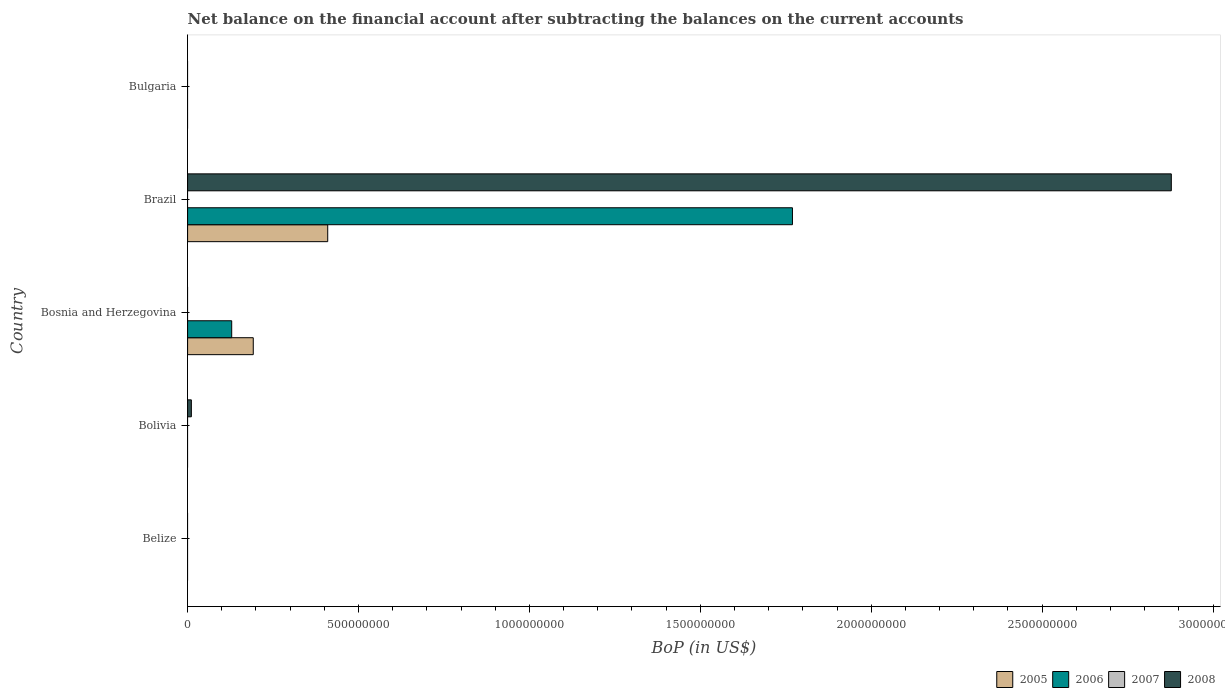How many different coloured bars are there?
Make the answer very short. 3. Are the number of bars per tick equal to the number of legend labels?
Provide a short and direct response. No. Are the number of bars on each tick of the Y-axis equal?
Your response must be concise. No. What is the label of the 2nd group of bars from the top?
Your answer should be very brief. Brazil. Across all countries, what is the maximum Balance of Payments in 2006?
Offer a very short reply. 1.77e+09. In which country was the Balance of Payments in 2006 maximum?
Keep it short and to the point. Brazil. What is the total Balance of Payments in 2005 in the graph?
Your response must be concise. 6.02e+08. What is the difference between the Balance of Payments in 2008 in Bolivia and that in Brazil?
Offer a very short reply. -2.87e+09. What is the difference between the Balance of Payments in 2006 in Brazil and the Balance of Payments in 2005 in Bosnia and Herzegovina?
Keep it short and to the point. 1.58e+09. What is the average Balance of Payments in 2007 per country?
Keep it short and to the point. 0. What is the difference between the Balance of Payments in 2006 and Balance of Payments in 2005 in Bosnia and Herzegovina?
Your response must be concise. -6.31e+07. In how many countries, is the Balance of Payments in 2007 greater than 600000000 US$?
Ensure brevity in your answer.  0. What is the ratio of the Balance of Payments in 2006 in Bosnia and Herzegovina to that in Brazil?
Offer a very short reply. 0.07. Is the Balance of Payments in 2006 in Bosnia and Herzegovina less than that in Brazil?
Offer a terse response. Yes. What is the difference between the highest and the lowest Balance of Payments in 2005?
Provide a short and direct response. 4.10e+08. In how many countries, is the Balance of Payments in 2006 greater than the average Balance of Payments in 2006 taken over all countries?
Make the answer very short. 1. Is the sum of the Balance of Payments in 2005 in Bosnia and Herzegovina and Brazil greater than the maximum Balance of Payments in 2006 across all countries?
Your response must be concise. No. What is the difference between two consecutive major ticks on the X-axis?
Your response must be concise. 5.00e+08. Does the graph contain any zero values?
Your answer should be compact. Yes. Does the graph contain grids?
Give a very brief answer. No. Where does the legend appear in the graph?
Give a very brief answer. Bottom right. How many legend labels are there?
Your answer should be compact. 4. What is the title of the graph?
Provide a succinct answer. Net balance on the financial account after subtracting the balances on the current accounts. What is the label or title of the X-axis?
Your answer should be very brief. BoP (in US$). What is the BoP (in US$) in 2005 in Belize?
Make the answer very short. 0. What is the BoP (in US$) in 2006 in Belize?
Give a very brief answer. 0. What is the BoP (in US$) of 2007 in Belize?
Ensure brevity in your answer.  0. What is the BoP (in US$) of 2005 in Bolivia?
Provide a succinct answer. 0. What is the BoP (in US$) of 2006 in Bolivia?
Provide a short and direct response. 0. What is the BoP (in US$) of 2007 in Bolivia?
Provide a short and direct response. 0. What is the BoP (in US$) in 2008 in Bolivia?
Your answer should be compact. 1.10e+07. What is the BoP (in US$) of 2005 in Bosnia and Herzegovina?
Offer a very short reply. 1.92e+08. What is the BoP (in US$) of 2006 in Bosnia and Herzegovina?
Keep it short and to the point. 1.29e+08. What is the BoP (in US$) of 2007 in Bosnia and Herzegovina?
Provide a short and direct response. 0. What is the BoP (in US$) of 2008 in Bosnia and Herzegovina?
Your answer should be very brief. 0. What is the BoP (in US$) in 2005 in Brazil?
Your response must be concise. 4.10e+08. What is the BoP (in US$) in 2006 in Brazil?
Keep it short and to the point. 1.77e+09. What is the BoP (in US$) of 2007 in Brazil?
Offer a very short reply. 0. What is the BoP (in US$) in 2008 in Brazil?
Provide a short and direct response. 2.88e+09. What is the BoP (in US$) in 2006 in Bulgaria?
Ensure brevity in your answer.  0. What is the BoP (in US$) in 2007 in Bulgaria?
Your answer should be compact. 0. What is the BoP (in US$) in 2008 in Bulgaria?
Keep it short and to the point. 0. Across all countries, what is the maximum BoP (in US$) in 2005?
Make the answer very short. 4.10e+08. Across all countries, what is the maximum BoP (in US$) of 2006?
Provide a succinct answer. 1.77e+09. Across all countries, what is the maximum BoP (in US$) of 2008?
Provide a succinct answer. 2.88e+09. Across all countries, what is the minimum BoP (in US$) in 2006?
Offer a terse response. 0. What is the total BoP (in US$) of 2005 in the graph?
Your response must be concise. 6.02e+08. What is the total BoP (in US$) in 2006 in the graph?
Provide a succinct answer. 1.90e+09. What is the total BoP (in US$) of 2007 in the graph?
Provide a succinct answer. 0. What is the total BoP (in US$) in 2008 in the graph?
Make the answer very short. 2.89e+09. What is the difference between the BoP (in US$) of 2008 in Bolivia and that in Brazil?
Your answer should be compact. -2.87e+09. What is the difference between the BoP (in US$) in 2005 in Bosnia and Herzegovina and that in Brazil?
Your answer should be compact. -2.18e+08. What is the difference between the BoP (in US$) of 2006 in Bosnia and Herzegovina and that in Brazil?
Your answer should be very brief. -1.64e+09. What is the difference between the BoP (in US$) of 2005 in Bosnia and Herzegovina and the BoP (in US$) of 2006 in Brazil?
Offer a very short reply. -1.58e+09. What is the difference between the BoP (in US$) of 2005 in Bosnia and Herzegovina and the BoP (in US$) of 2008 in Brazil?
Offer a terse response. -2.69e+09. What is the difference between the BoP (in US$) of 2006 in Bosnia and Herzegovina and the BoP (in US$) of 2008 in Brazil?
Provide a short and direct response. -2.75e+09. What is the average BoP (in US$) of 2005 per country?
Ensure brevity in your answer.  1.20e+08. What is the average BoP (in US$) in 2006 per country?
Your answer should be compact. 3.80e+08. What is the average BoP (in US$) of 2008 per country?
Your answer should be compact. 5.78e+08. What is the difference between the BoP (in US$) in 2005 and BoP (in US$) in 2006 in Bosnia and Herzegovina?
Give a very brief answer. 6.31e+07. What is the difference between the BoP (in US$) in 2005 and BoP (in US$) in 2006 in Brazil?
Your answer should be very brief. -1.36e+09. What is the difference between the BoP (in US$) in 2005 and BoP (in US$) in 2008 in Brazil?
Your answer should be very brief. -2.47e+09. What is the difference between the BoP (in US$) of 2006 and BoP (in US$) of 2008 in Brazil?
Offer a very short reply. -1.11e+09. What is the ratio of the BoP (in US$) of 2008 in Bolivia to that in Brazil?
Your answer should be compact. 0. What is the ratio of the BoP (in US$) in 2005 in Bosnia and Herzegovina to that in Brazil?
Provide a succinct answer. 0.47. What is the ratio of the BoP (in US$) of 2006 in Bosnia and Herzegovina to that in Brazil?
Your answer should be compact. 0.07. What is the difference between the highest and the lowest BoP (in US$) of 2005?
Your answer should be compact. 4.10e+08. What is the difference between the highest and the lowest BoP (in US$) in 2006?
Provide a short and direct response. 1.77e+09. What is the difference between the highest and the lowest BoP (in US$) of 2008?
Your answer should be compact. 2.88e+09. 